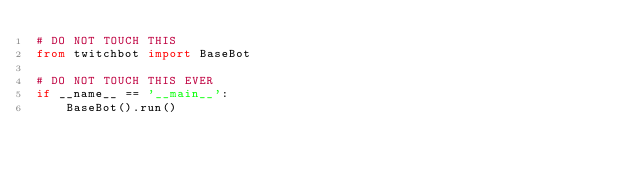Convert code to text. <code><loc_0><loc_0><loc_500><loc_500><_Python_># DO NOT TOUCH THIS
from twitchbot import BaseBot

# DO NOT TOUCH THIS EVER
if __name__ == '__main__':
    BaseBot().run()</code> 